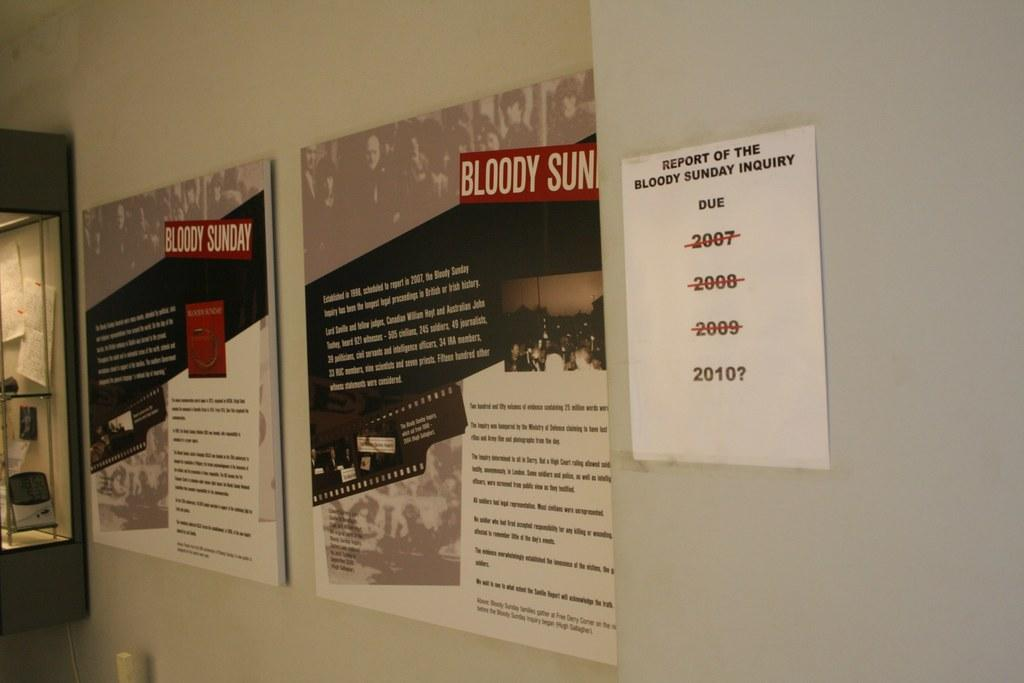<image>
Share a concise interpretation of the image provided. a hallway with two posters about bloody sunday on the walls 